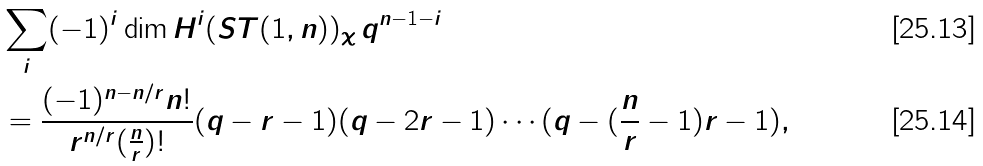<formula> <loc_0><loc_0><loc_500><loc_500>& \sum _ { i } ( - 1 ) ^ { i } \dim H ^ { i } ( S T ( 1 , n ) ) _ { \chi } \, q ^ { n - 1 - i } \\ & = \frac { ( - 1 ) ^ { n - n / r } n ! } { r ^ { n / r } ( \frac { n } { r } ) ! } ( q - r - 1 ) ( q - 2 r - 1 ) \cdots ( q - ( \frac { n } { r } - 1 ) r - 1 ) ,</formula> 